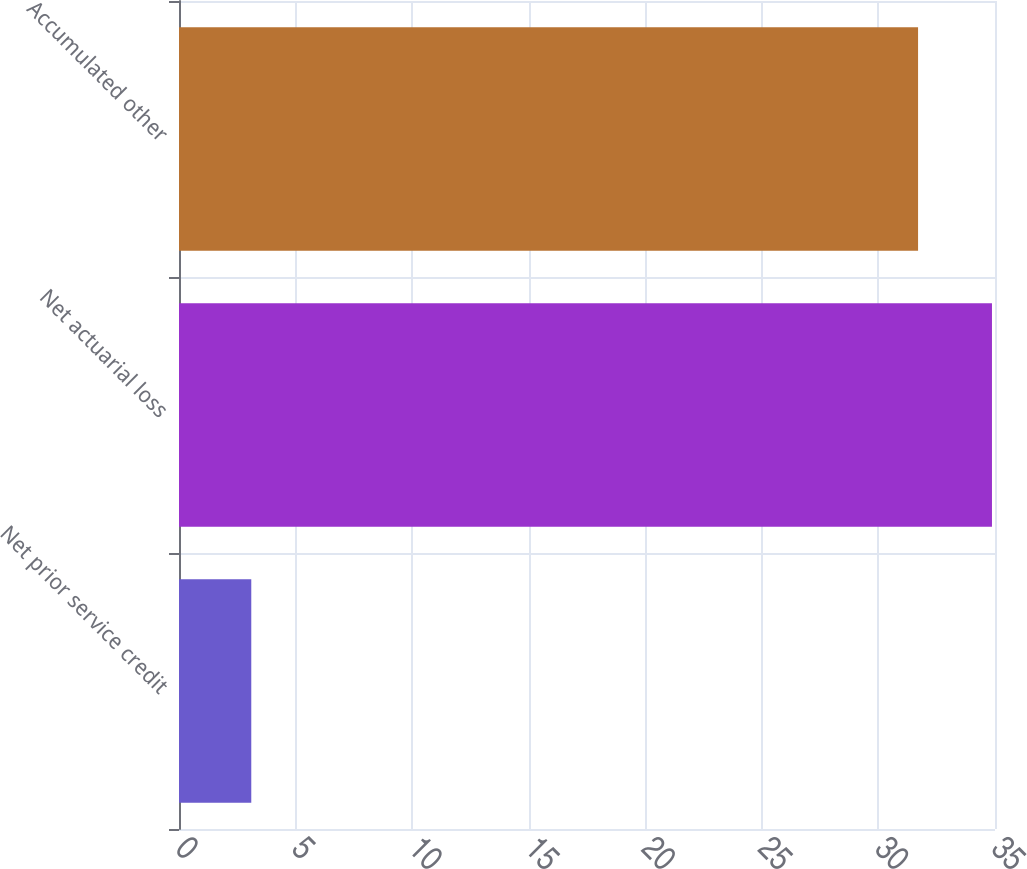<chart> <loc_0><loc_0><loc_500><loc_500><bar_chart><fcel>Net prior service credit<fcel>Net actuarial loss<fcel>Accumulated other<nl><fcel>3.1<fcel>34.87<fcel>31.7<nl></chart> 